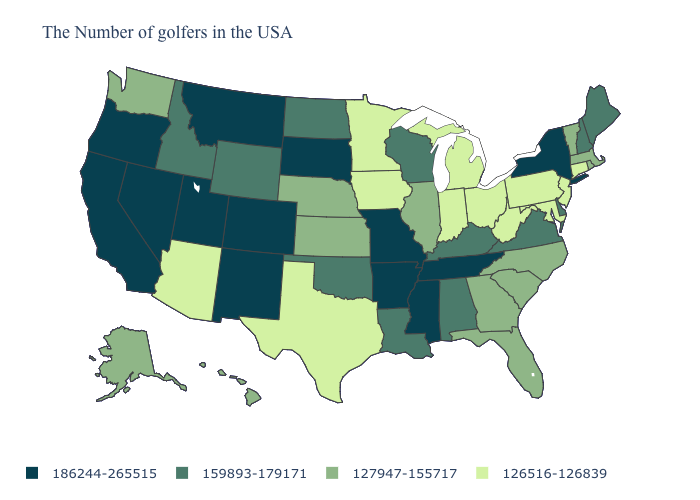Among the states that border California , does Arizona have the lowest value?
Be succinct. Yes. Name the states that have a value in the range 126516-126839?
Keep it brief. Connecticut, New Jersey, Maryland, Pennsylvania, West Virginia, Ohio, Michigan, Indiana, Minnesota, Iowa, Texas, Arizona. Name the states that have a value in the range 127947-155717?
Write a very short answer. Massachusetts, Rhode Island, Vermont, North Carolina, South Carolina, Florida, Georgia, Illinois, Kansas, Nebraska, Washington, Alaska, Hawaii. What is the value of Idaho?
Short answer required. 159893-179171. Does the map have missing data?
Answer briefly. No. Among the states that border Arkansas , does Missouri have the highest value?
Concise answer only. Yes. Does Arizona have the lowest value in the West?
Answer briefly. Yes. What is the highest value in states that border Massachusetts?
Write a very short answer. 186244-265515. Is the legend a continuous bar?
Be succinct. No. Does Utah have the highest value in the West?
Keep it brief. Yes. Does Delaware have the lowest value in the USA?
Write a very short answer. No. What is the lowest value in the West?
Give a very brief answer. 126516-126839. Name the states that have a value in the range 186244-265515?
Answer briefly. New York, Tennessee, Mississippi, Missouri, Arkansas, South Dakota, Colorado, New Mexico, Utah, Montana, Nevada, California, Oregon. Name the states that have a value in the range 126516-126839?
Quick response, please. Connecticut, New Jersey, Maryland, Pennsylvania, West Virginia, Ohio, Michigan, Indiana, Minnesota, Iowa, Texas, Arizona. Does the map have missing data?
Short answer required. No. 